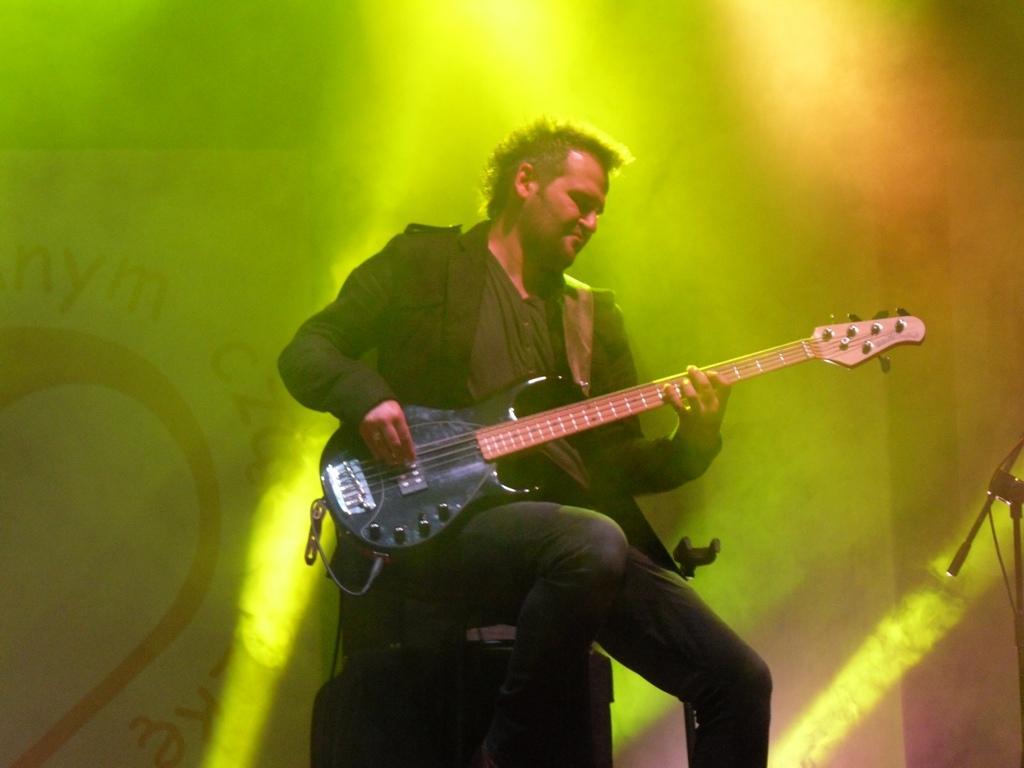Please provide a concise description of this image. In this image there is a man who is playing the guitar by sitting on the chair. At the top there are lights. In the background there is a banner. On the right side there is a stand. 